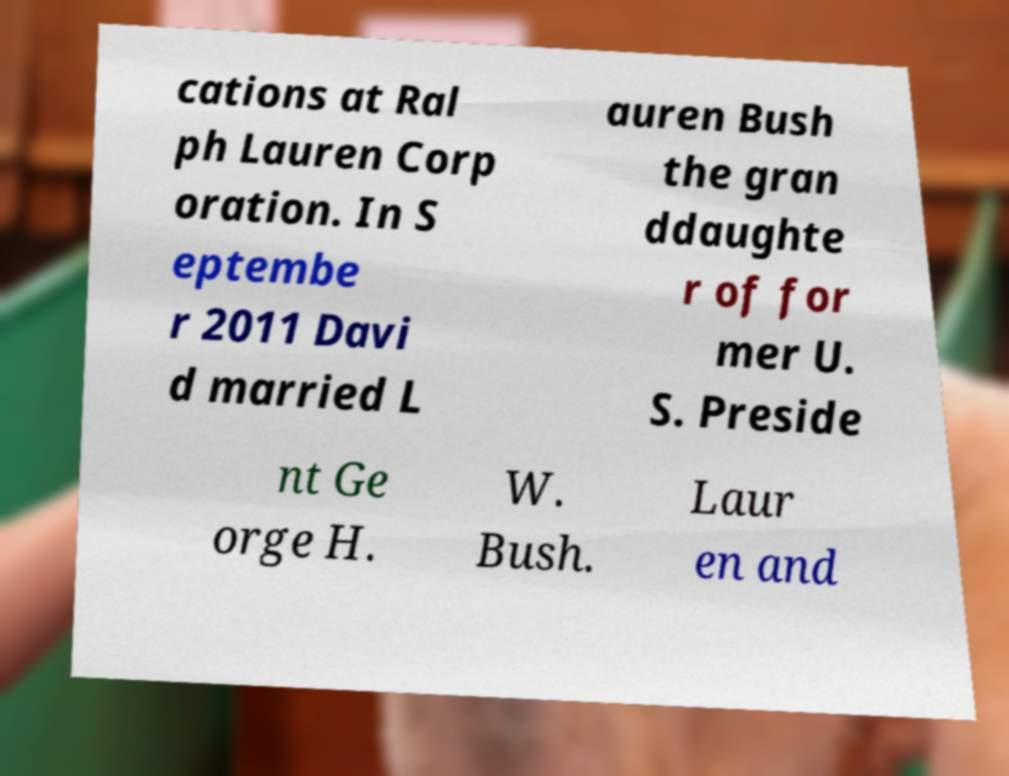Could you extract and type out the text from this image? cations at Ral ph Lauren Corp oration. In S eptembe r 2011 Davi d married L auren Bush the gran ddaughte r of for mer U. S. Preside nt Ge orge H. W. Bush. Laur en and 